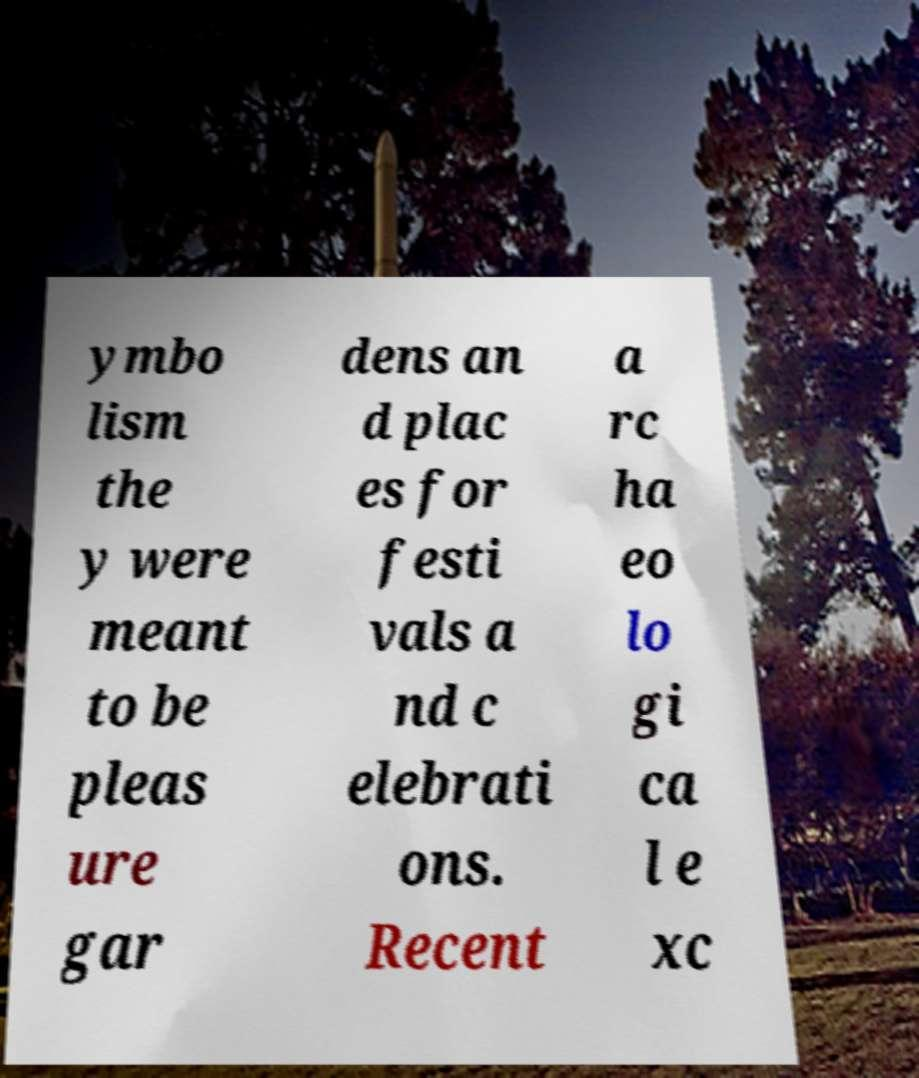For documentation purposes, I need the text within this image transcribed. Could you provide that? ymbo lism the y were meant to be pleas ure gar dens an d plac es for festi vals a nd c elebrati ons. Recent a rc ha eo lo gi ca l e xc 